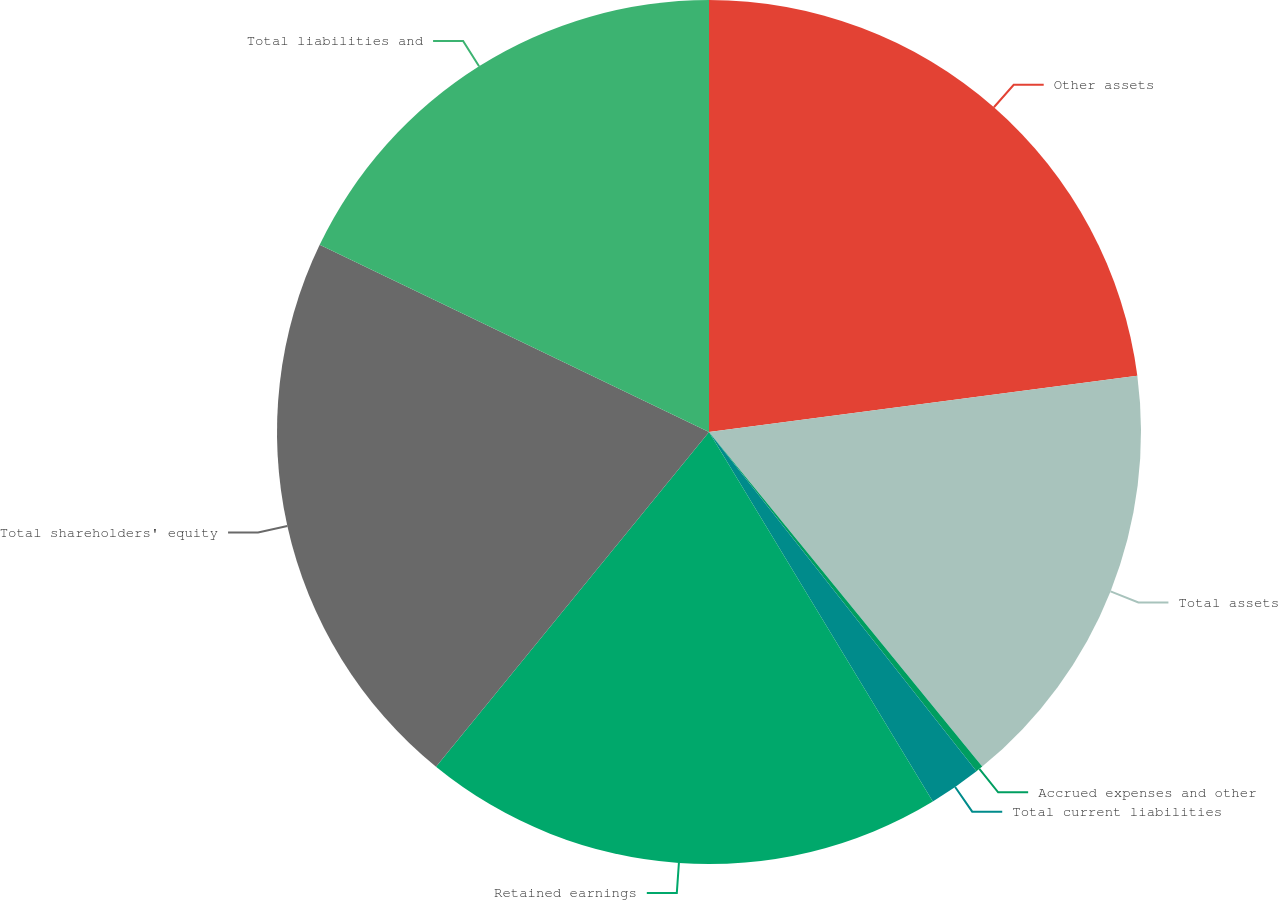Convert chart. <chart><loc_0><loc_0><loc_500><loc_500><pie_chart><fcel>Other assets<fcel>Total assets<fcel>Accrued expenses and other<fcel>Total current liabilities<fcel>Retained earnings<fcel>Total shareholders' equity<fcel>Total liabilities and<nl><fcel>22.93%<fcel>16.18%<fcel>0.27%<fcel>1.96%<fcel>19.56%<fcel>21.25%<fcel>17.87%<nl></chart> 